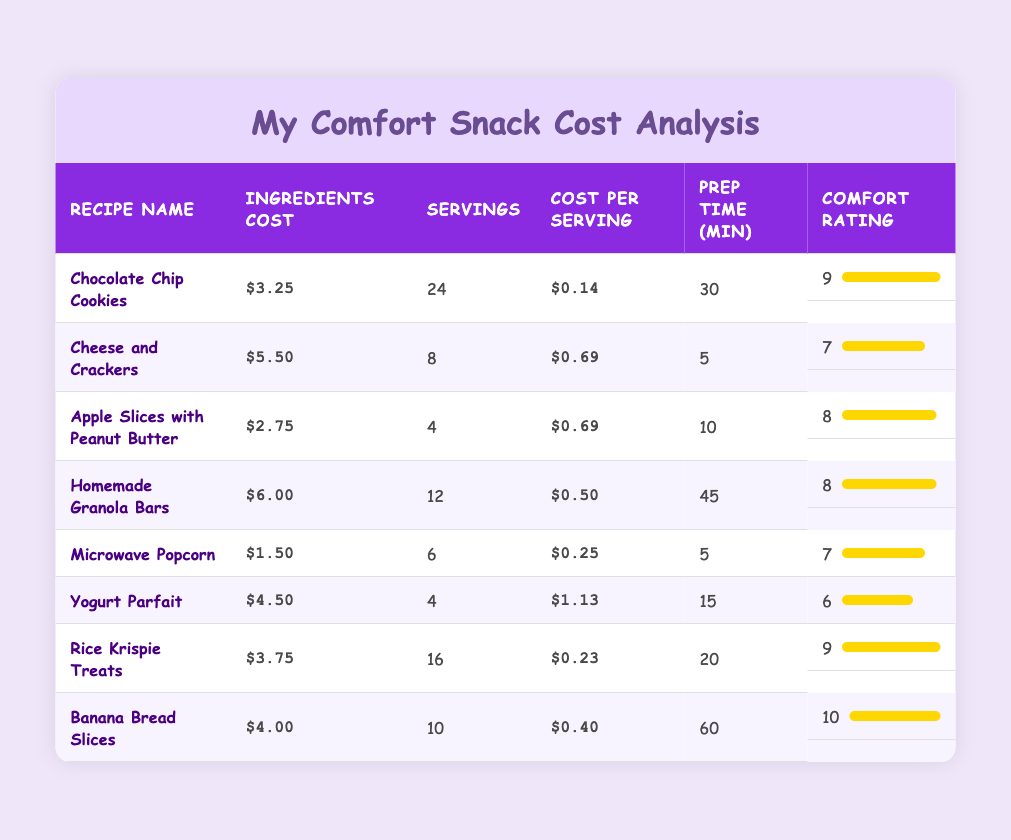What is the cost per serving of Banana Bread Slices? The cost per serving of Banana Bread Slices is listed in the table under the "Cost per Serving" column, which shows $0.40 for this recipe.
Answer: $0.40 Which homemade snack has the highest comfort rating? The comfort ratings are listed in the table, and the highest rating, which is 10, is for Banana Bread Slices.
Answer: Banana Bread Slices How much does it cost for all servings of Chocolate Chip Cookies? To find the total cost for all servings, multiply the cost per serving ($0.14) by the number of servings (24). This calculation is 0.14 * 24 = 3.36.
Answer: $3.36 Is the preparation time for Rice Krispie Treats longer than that for Microwave Popcorn? The preparation time for Rice Krispie Treats is 20 minutes while Microwave Popcorn takes 5 minutes, so Rice Krispie Treats takes longer.
Answer: Yes What is the average cost per serving of all snacks combined? To find the average, sum all the cost per serving values: 0.14 + 0.69 + 0.69 + 0.50 + 0.25 + 1.13 + 0.23 + 0.40. There are 8 snacks total, so the sum is 3.22, and the average cost per serving is 3.22 divided by 8, which equals approximately 0.40.
Answer: 0.40 How many snacks have a comfort rating of 8 or above? Checking the comfort ratings, we see that there are 4 snacks with ratings of 8 or above: Chocolate Chip Cookies, Apple Slices with Peanut Butter, Homemade Granola Bars, Rice Krispie Treats, and Banana Bread Slices.
Answer: 5 Which snack has the lowest ingredients cost? The ingredients cost for each snack is listed, and the lowest cost is for Microwave Popcorn at $1.50.
Answer: Microwave Popcorn How many servings do you get for the cost of ingredients used for Yogurt Parfait? The cost of ingredients for Yogurt Parfait is $4.50, and it provides 4 servings. Therefore, you get 4 servings for the $4.50 cost.
Answer: 4 servings 